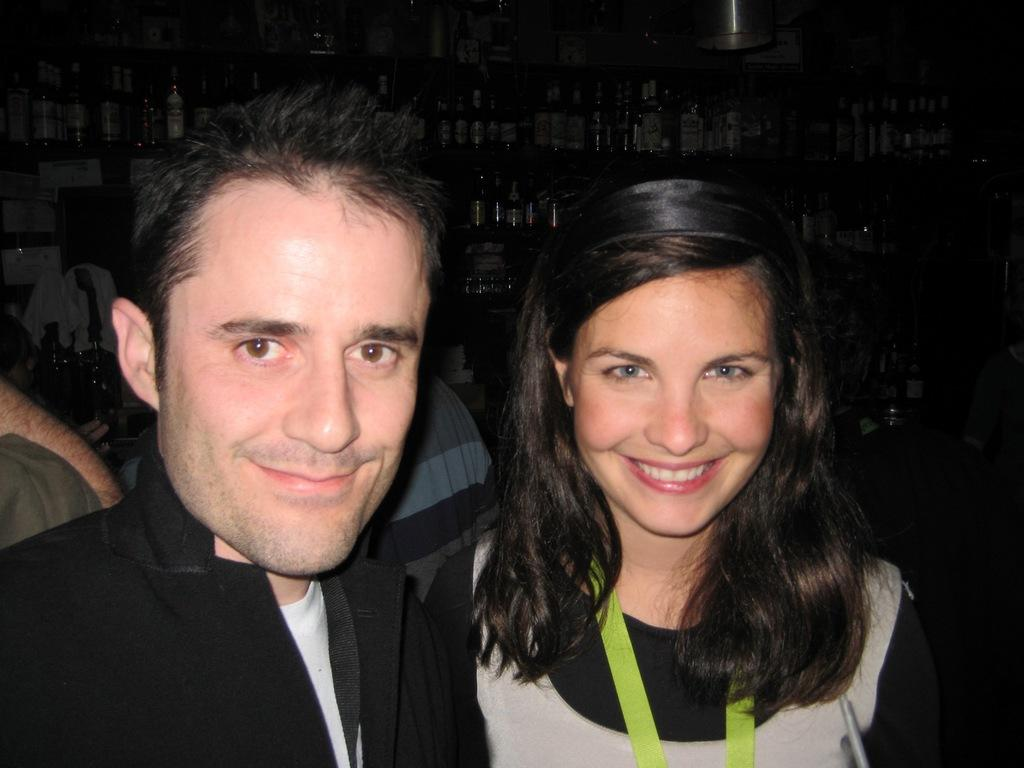Who are the people in the image? There is a man and a woman in the image. What are the expressions on their faces? Both the man and the woman are smiling. Can you describe the people in the background of the image? There are people visible in the background of the image. What can be seen on the shelves in the image? There are many bottles arranged on shelves in the image. What type of bells can be heard ringing in the image? There are no bells present in the image, and therefore no sound can be heard. 